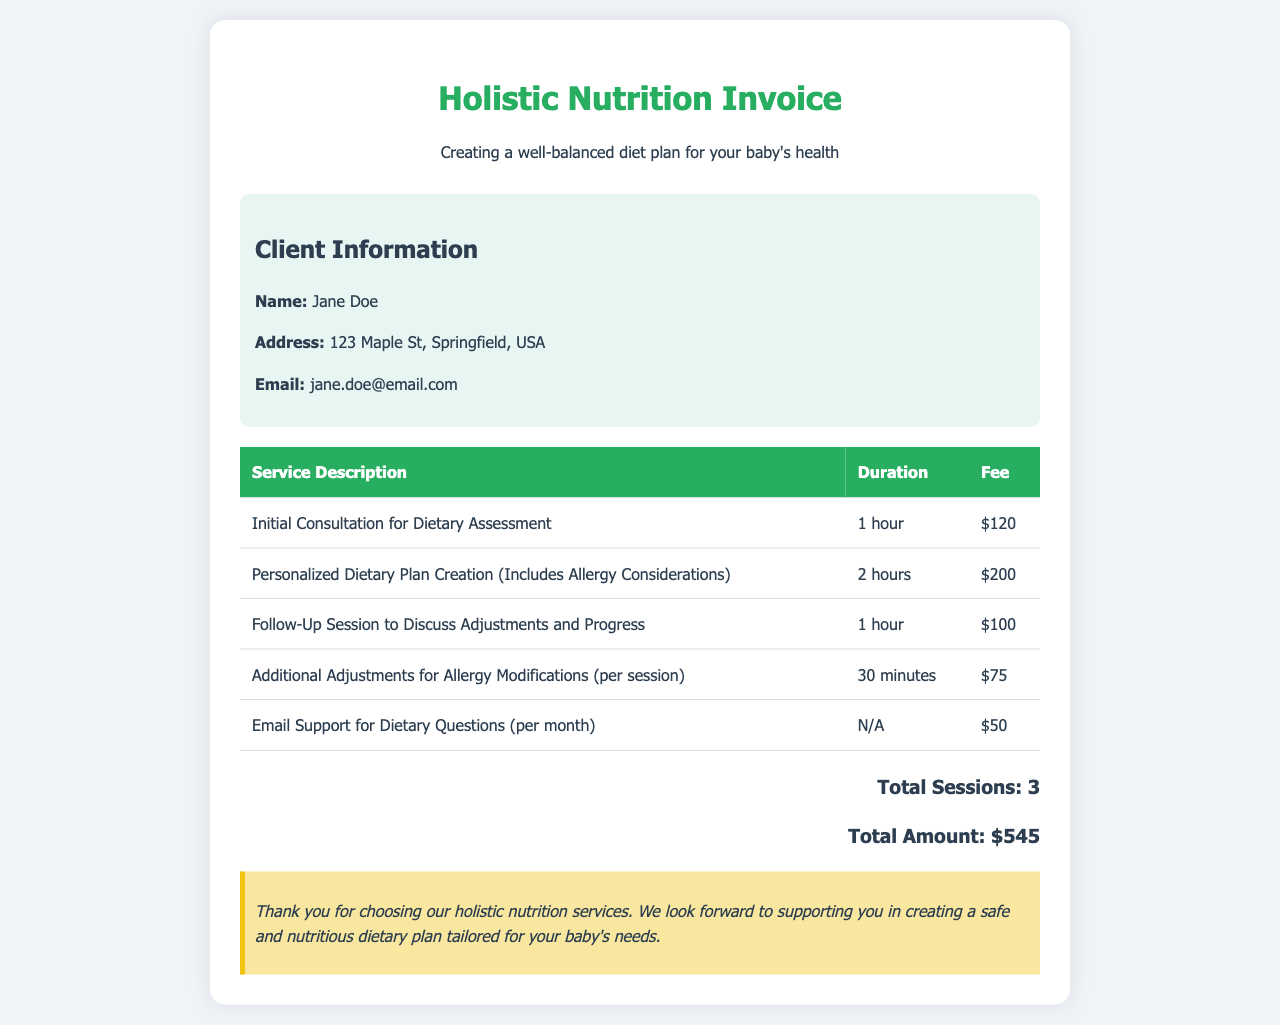What is the name of the client? The client's name is listed in the client information section of the document.
Answer: Jane Doe How much is the fee for the initial consultation? This information can be found in the itemized list of services and their corresponding fees.
Answer: $120 What is the total amount charged for services? The total amount is presented at the bottom of the invoice, summarizing all fees.
Answer: $545 How many sessions are included in this invoice? The total number of sessions is stated at the bottom of the invoice.
Answer: 3 What is the duration of the follow-up session? The duration of the follow-up session is detailed in the service description table.
Answer: 1 hour Which service includes allergy considerations? This detail is mentioned in the description of one of the services provided.
Answer: Personalized Dietary Plan Creation What is the fee for email support per month? The fee for email support is specified in the itemized services section.
Answer: $50 What type of support is offered per month besides sessions? This type of support is detailed in the itemized services and their corresponding descriptions.
Answer: Email Support for Dietary Questions How long is the additional adjustments session for allergy modifications? The duration of this service is mentioned in the itemized list of services.
Answer: 30 minutes 